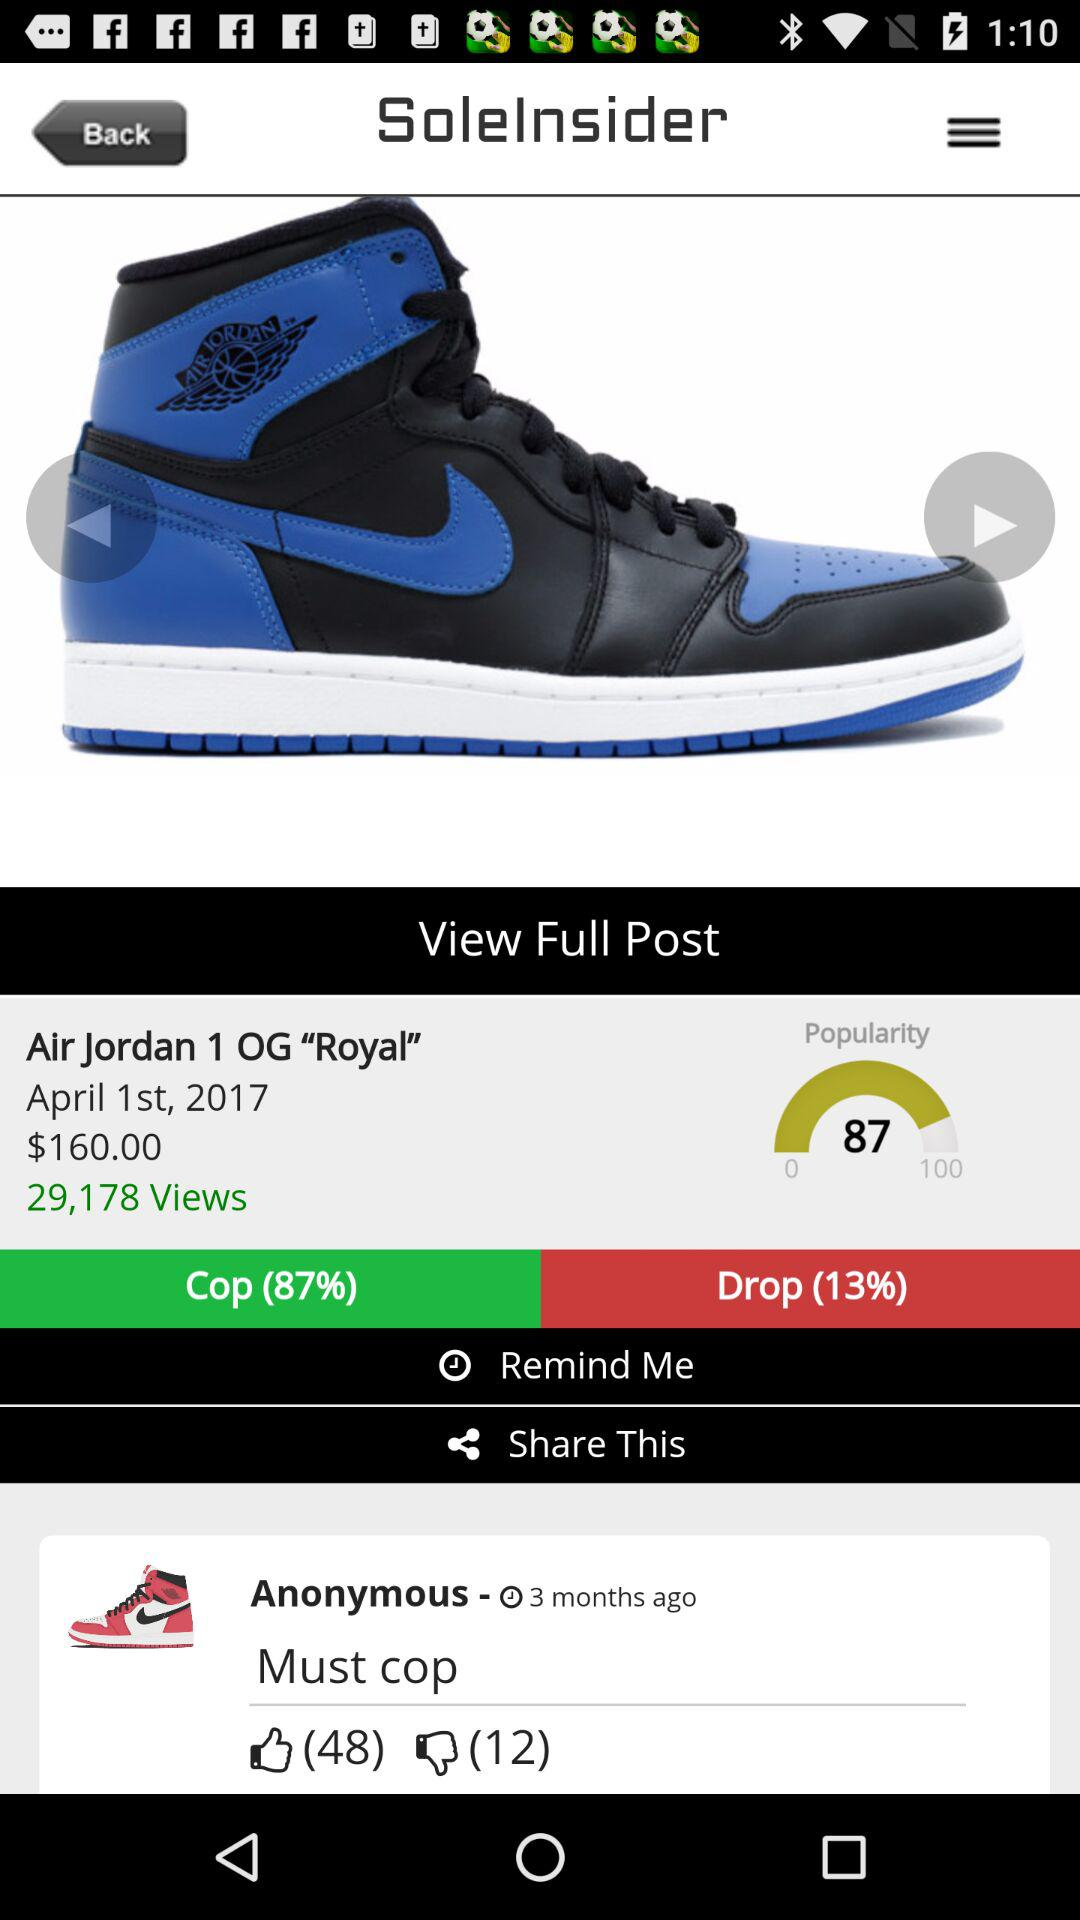How many people have liked the review "Must cop"? There are 48 people who have liked the review "Must cop". 